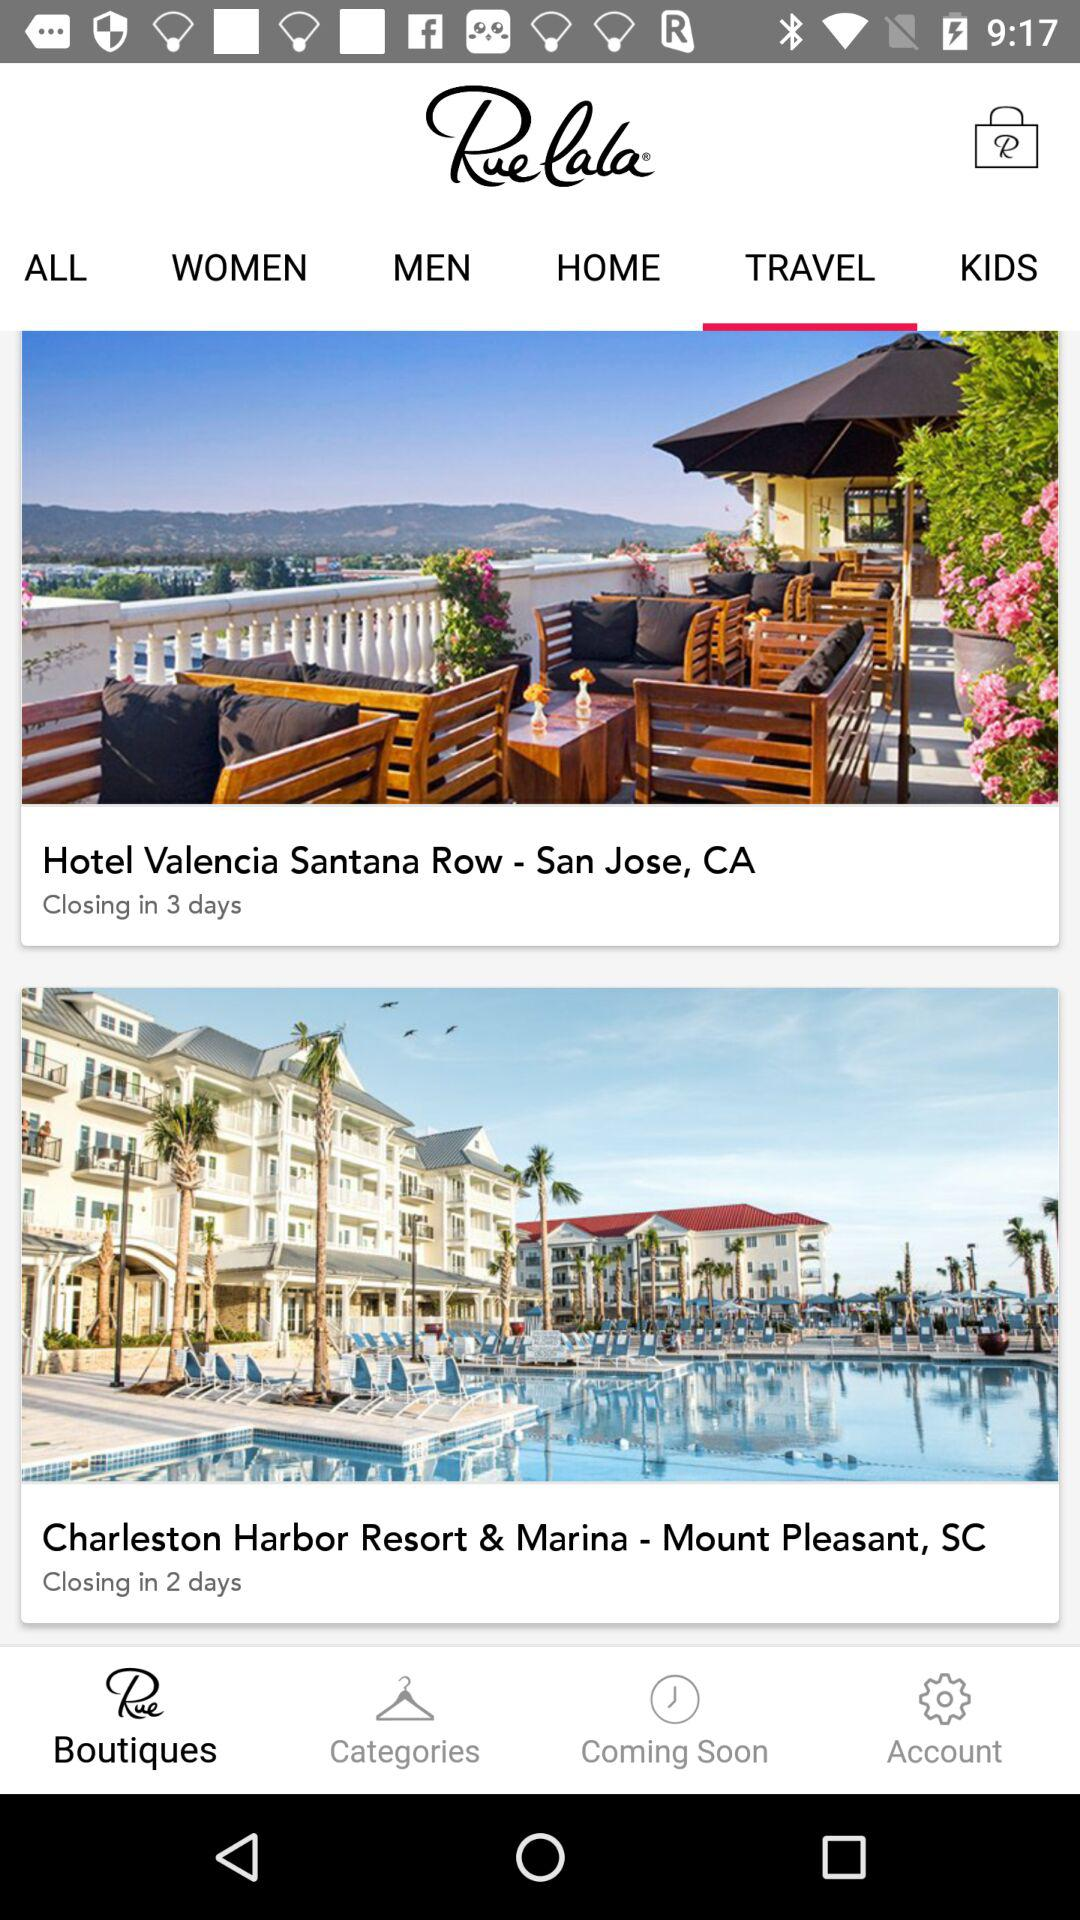What is the address of "Hotel Valencia Santana Row"? The address of "Hotel Valencia Santana Row" is San Jose, CA. 